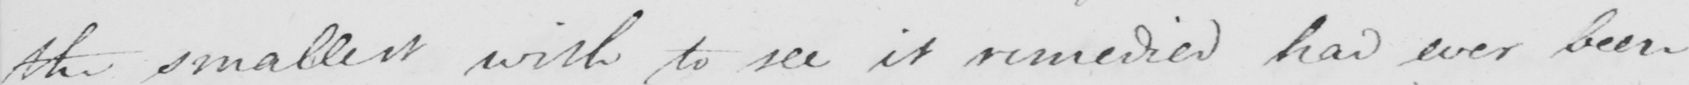What is written in this line of handwriting? the smallest wish to see it remedied had ever been 